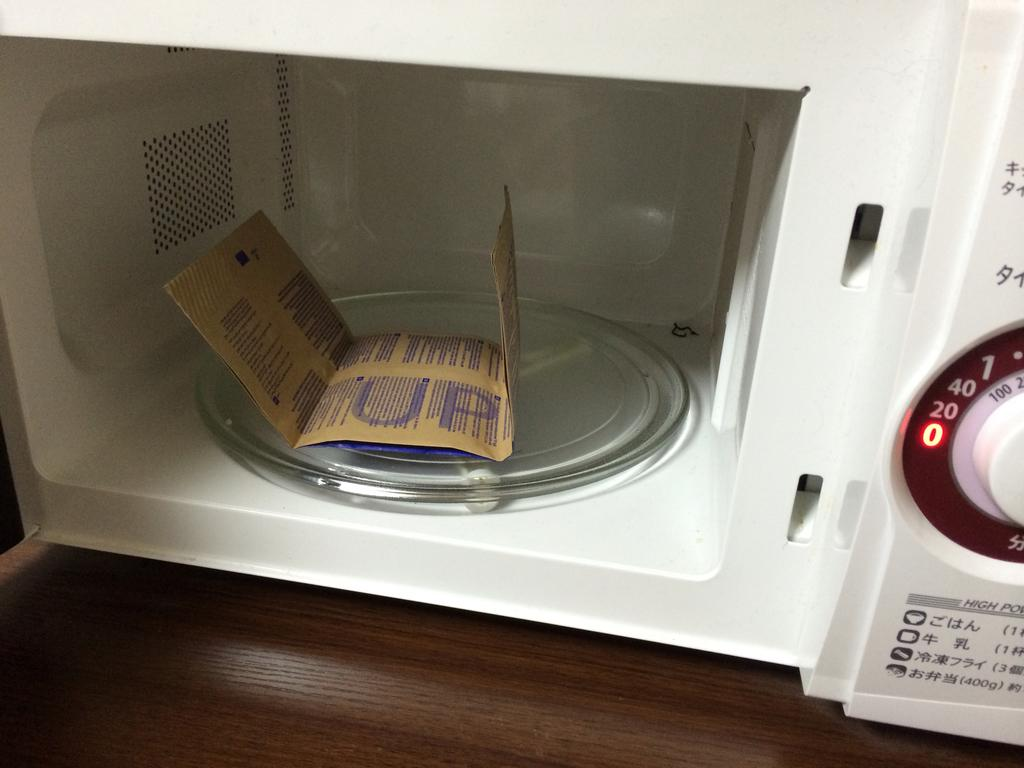<image>
Provide a brief description of the given image. A bag of popcorn in the microwave showing the UP side 